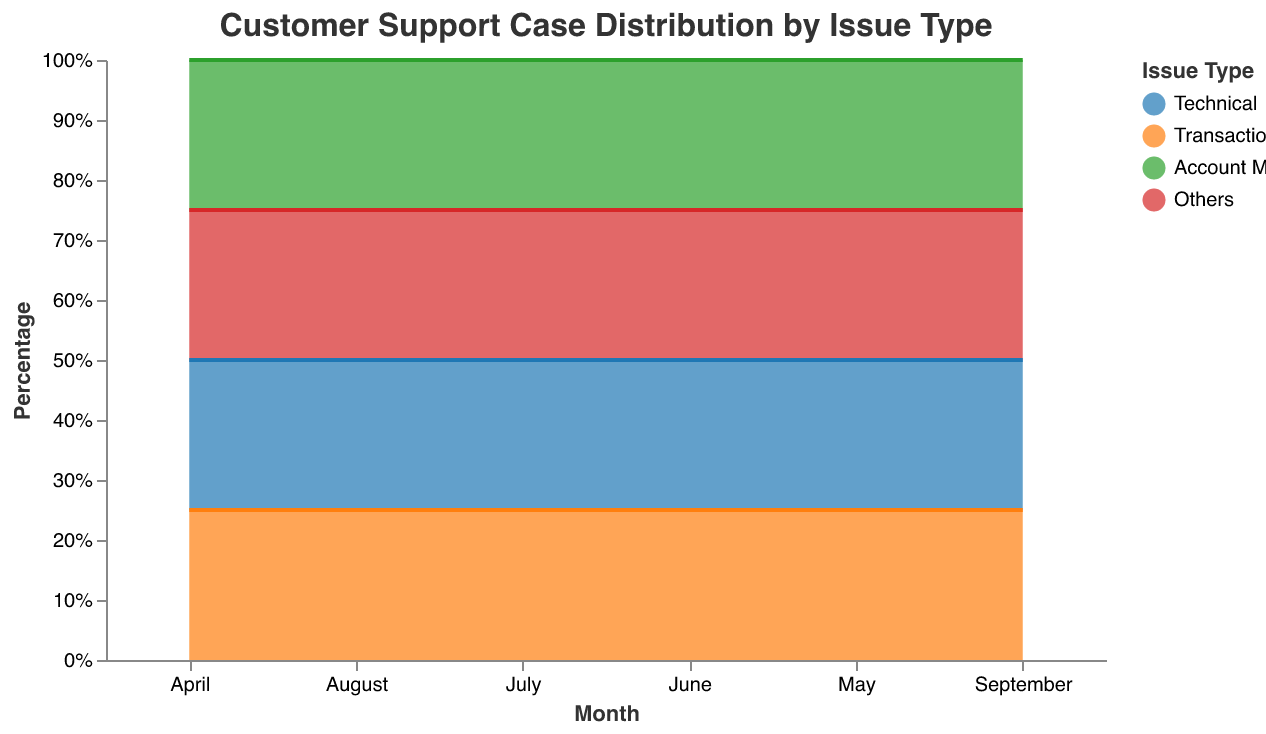What is the title of the figure? The title of the figure is the text at the top which describes the overall content being shown.
Answer: Customer Support Case Distribution by Issue Type Which month shows the highest proportion of 'Transactional' issues? The 'Transactional' issue will be represented by the section with a specific color (shown in the legend) that has the largest vertical height in the figure. Inspect each month and identify where the 'Transactional' segment has the highest proportion.
Answer: September What are the four types of issues displayed in the chart? The issue types are specified in the legend on the right side of the chart. Each type corresponds to a color in the stacked area chart.
Answer: Technical, Transactional, Account Management, Others Which issue type has consistently decreased its proportion over the six months? Look at each issue type across the six months and observe changes in their vertical heights: if it consistently becomes smaller, it indicates a decrease.
Answer: Technical In which month did 'Account Management' issues peak? Observe the segment corresponding to 'Account Management' across all months and note when it reaches its highest vertical height.
Answer: June What is the sum of 'Technical' cases reported in April and May? Find the values for 'Technical' cases in April and May and add them together.
Answer: 65 Compare the percentages of 'Others' issues in April and September. Which month has a higher percentage? Examine the vertical heights of 'Others' in April and September and compare them to see which month's 'Others' segment is larger.
Answer: April How does the proportion of 'Transactional' cases in May compare to that in June? Check the vertical height of 'Transactional' segments for May and June and note which one is higher.
Answer: June is higher What's the trend for 'Technical' issues from April to September? Observe the 'Technical' segments across all months and assess whether the height increases, decreases, or remains stable over time.
Answer: Decreasing How do 'Account Management' issues in July compare to August? Compare the vertical heights of 'Account Management' segments in July and August to see which one is larger.
Answer: July is higher 